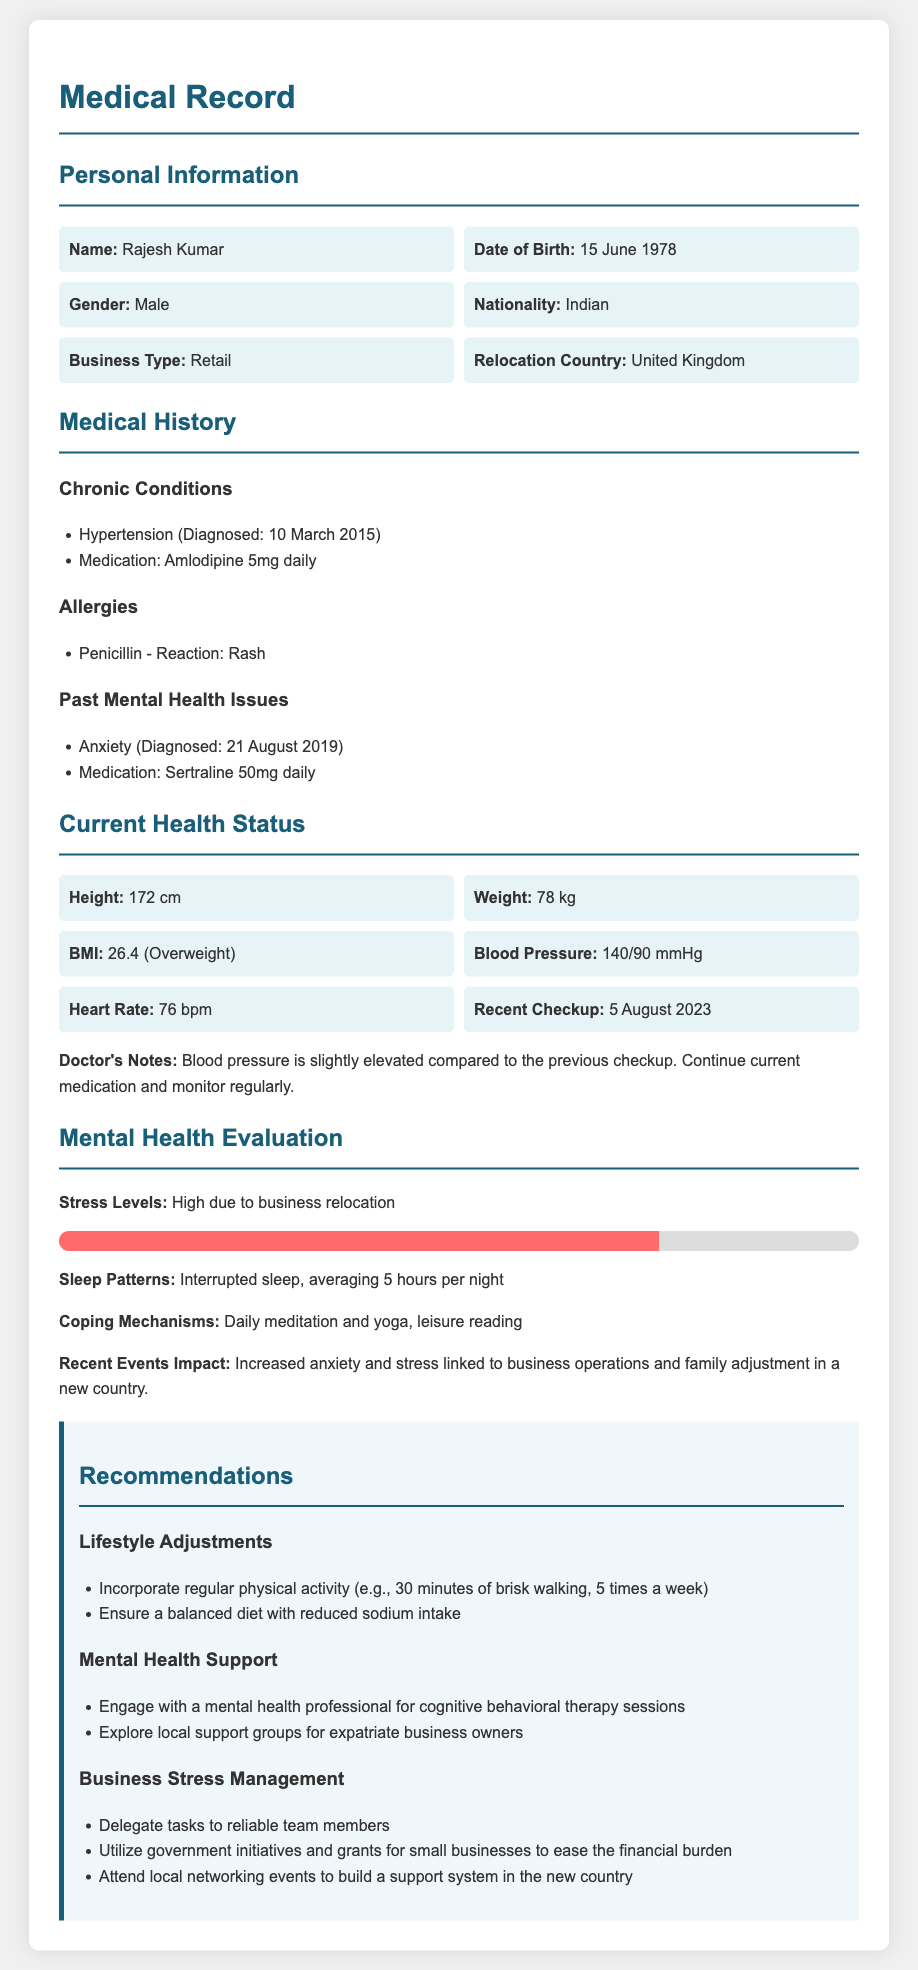What is the name of the patient? The name of the patient is mentioned in the personal information section.
Answer: Rajesh Kumar When was hypertension diagnosed? The date of hypertension diagnosis is specified in the medical history section.
Answer: 10 March 2015 What medication is prescribed for anxiety? The medication for anxiety is listed under past mental health issues.
Answer: Sertraline 50mg daily What is Rajesh's BMI? The BMI value is provided in the current health status section.
Answer: 26.4 How many hours of sleep does Rajesh average per night? The average hours of sleep are noted in the mental health evaluation section.
Answer: 5 hours What coping mechanism is mentioned? The coping mechanisms used by Rajesh are detailed in the mental health evaluation section.
Answer: Daily meditation and yoga What is the recommended physical activity frequency? The recommendations section outlines suggested physical activity frequency.
Answer: 5 times a week What type of therapy is recommended for mental health support? The recommended therapy type is found within the mental health support section of recommendations.
Answer: Cognitive behavioral therapy sessions What government initiative is suggested for small businesses? The recommendations for business stress management include a suggestion related to government initiatives.
Answer: Utilize government initiatives and grants for small businesses 